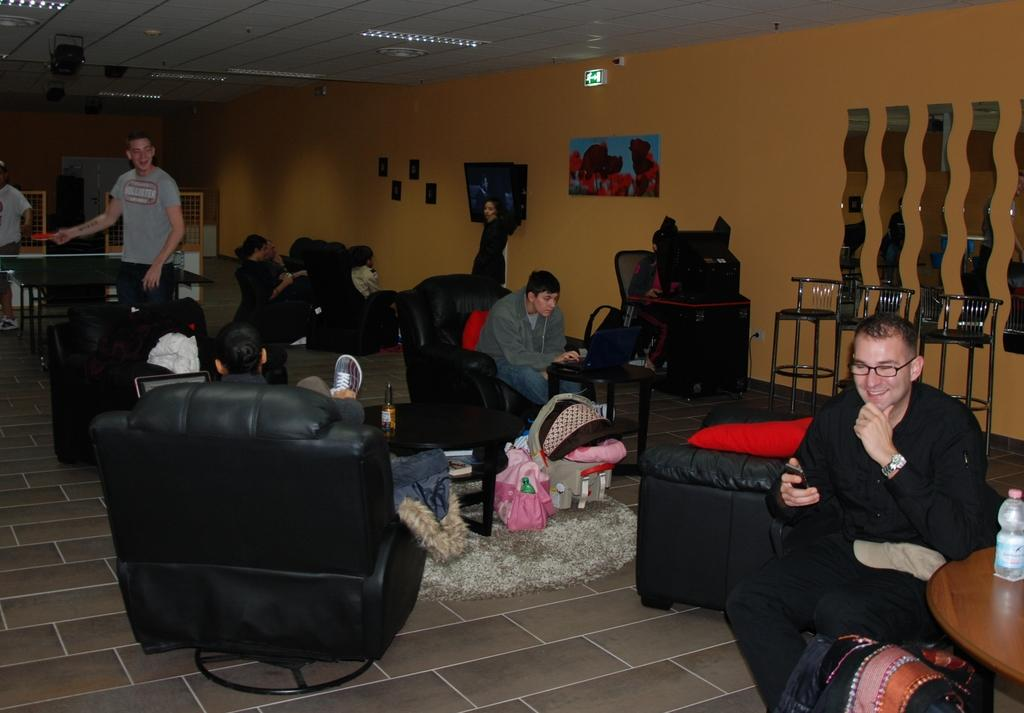How many individuals are present in the image? There are many people in the image. What are the people doing in the image? The people are sitting on a chair and doing some work. What month is it in the image? The month is not mentioned or depicted in the image. What disease are the people suffering from in the image? There is no indication of any disease in the image; the people are simply sitting and working. 